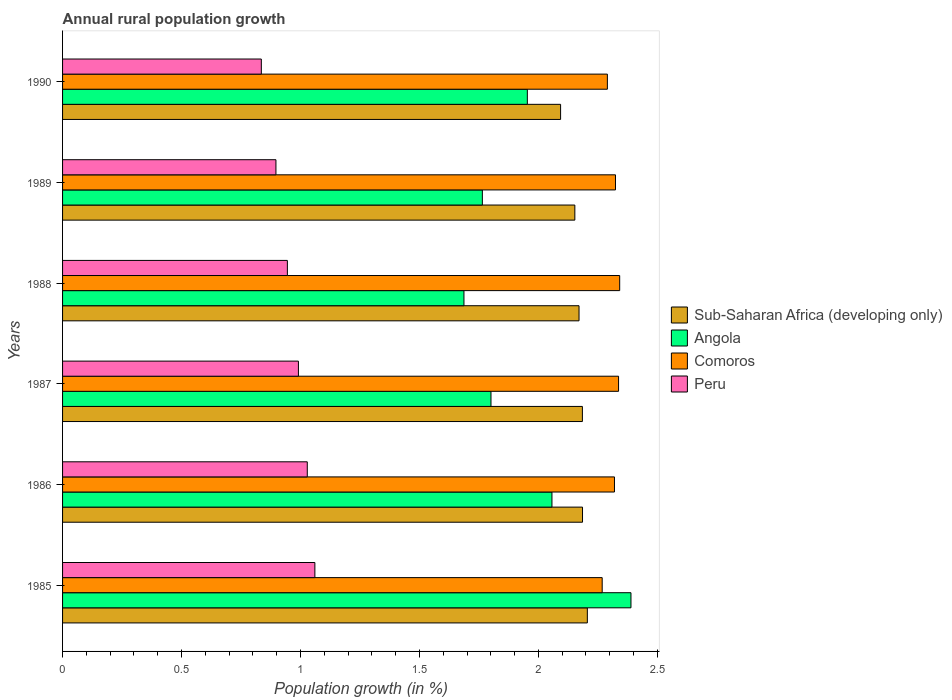How many different coloured bars are there?
Provide a short and direct response. 4. What is the percentage of rural population growth in Peru in 1989?
Provide a succinct answer. 0.9. Across all years, what is the maximum percentage of rural population growth in Peru?
Offer a very short reply. 1.06. Across all years, what is the minimum percentage of rural population growth in Peru?
Make the answer very short. 0.84. In which year was the percentage of rural population growth in Angola maximum?
Your response must be concise. 1985. What is the total percentage of rural population growth in Angola in the graph?
Give a very brief answer. 11.65. What is the difference between the percentage of rural population growth in Comoros in 1989 and that in 1990?
Offer a terse response. 0.03. What is the difference between the percentage of rural population growth in Sub-Saharan Africa (developing only) in 1987 and the percentage of rural population growth in Peru in 1989?
Offer a terse response. 1.29. What is the average percentage of rural population growth in Angola per year?
Your answer should be very brief. 1.94. In the year 1987, what is the difference between the percentage of rural population growth in Comoros and percentage of rural population growth in Peru?
Provide a succinct answer. 1.35. In how many years, is the percentage of rural population growth in Comoros greater than 0.30000000000000004 %?
Provide a succinct answer. 6. What is the ratio of the percentage of rural population growth in Sub-Saharan Africa (developing only) in 1985 to that in 1988?
Your response must be concise. 1.02. Is the percentage of rural population growth in Sub-Saharan Africa (developing only) in 1986 less than that in 1990?
Offer a terse response. No. What is the difference between the highest and the second highest percentage of rural population growth in Sub-Saharan Africa (developing only)?
Offer a terse response. 0.02. What is the difference between the highest and the lowest percentage of rural population growth in Peru?
Keep it short and to the point. 0.23. In how many years, is the percentage of rural population growth in Angola greater than the average percentage of rural population growth in Angola taken over all years?
Give a very brief answer. 3. Is it the case that in every year, the sum of the percentage of rural population growth in Sub-Saharan Africa (developing only) and percentage of rural population growth in Peru is greater than the sum of percentage of rural population growth in Angola and percentage of rural population growth in Comoros?
Keep it short and to the point. Yes. What does the 2nd bar from the top in 1987 represents?
Your response must be concise. Comoros. What does the 2nd bar from the bottom in 1990 represents?
Provide a succinct answer. Angola. How many years are there in the graph?
Ensure brevity in your answer.  6. Are the values on the major ticks of X-axis written in scientific E-notation?
Offer a very short reply. No. Does the graph contain any zero values?
Offer a terse response. No. Does the graph contain grids?
Give a very brief answer. No. Where does the legend appear in the graph?
Make the answer very short. Center right. What is the title of the graph?
Your answer should be compact. Annual rural population growth. What is the label or title of the X-axis?
Offer a very short reply. Population growth (in %). What is the Population growth (in %) in Sub-Saharan Africa (developing only) in 1985?
Your response must be concise. 2.21. What is the Population growth (in %) of Angola in 1985?
Offer a terse response. 2.39. What is the Population growth (in %) in Comoros in 1985?
Offer a terse response. 2.27. What is the Population growth (in %) of Peru in 1985?
Provide a short and direct response. 1.06. What is the Population growth (in %) of Sub-Saharan Africa (developing only) in 1986?
Provide a succinct answer. 2.19. What is the Population growth (in %) of Angola in 1986?
Provide a short and direct response. 2.06. What is the Population growth (in %) in Comoros in 1986?
Your response must be concise. 2.32. What is the Population growth (in %) in Peru in 1986?
Provide a succinct answer. 1.03. What is the Population growth (in %) of Sub-Saharan Africa (developing only) in 1987?
Keep it short and to the point. 2.18. What is the Population growth (in %) in Angola in 1987?
Provide a succinct answer. 1.8. What is the Population growth (in %) in Comoros in 1987?
Ensure brevity in your answer.  2.34. What is the Population growth (in %) in Peru in 1987?
Provide a short and direct response. 0.99. What is the Population growth (in %) in Sub-Saharan Africa (developing only) in 1988?
Make the answer very short. 2.17. What is the Population growth (in %) of Angola in 1988?
Provide a succinct answer. 1.69. What is the Population growth (in %) of Comoros in 1988?
Offer a terse response. 2.34. What is the Population growth (in %) in Peru in 1988?
Your answer should be very brief. 0.94. What is the Population growth (in %) of Sub-Saharan Africa (developing only) in 1989?
Your answer should be very brief. 2.15. What is the Population growth (in %) of Angola in 1989?
Ensure brevity in your answer.  1.76. What is the Population growth (in %) of Comoros in 1989?
Keep it short and to the point. 2.32. What is the Population growth (in %) in Peru in 1989?
Keep it short and to the point. 0.9. What is the Population growth (in %) of Sub-Saharan Africa (developing only) in 1990?
Ensure brevity in your answer.  2.09. What is the Population growth (in %) of Angola in 1990?
Keep it short and to the point. 1.95. What is the Population growth (in %) of Comoros in 1990?
Give a very brief answer. 2.29. What is the Population growth (in %) of Peru in 1990?
Offer a terse response. 0.84. Across all years, what is the maximum Population growth (in %) of Sub-Saharan Africa (developing only)?
Offer a very short reply. 2.21. Across all years, what is the maximum Population growth (in %) in Angola?
Your response must be concise. 2.39. Across all years, what is the maximum Population growth (in %) in Comoros?
Give a very brief answer. 2.34. Across all years, what is the maximum Population growth (in %) of Peru?
Offer a very short reply. 1.06. Across all years, what is the minimum Population growth (in %) in Sub-Saharan Africa (developing only)?
Give a very brief answer. 2.09. Across all years, what is the minimum Population growth (in %) of Angola?
Your answer should be very brief. 1.69. Across all years, what is the minimum Population growth (in %) of Comoros?
Offer a terse response. 2.27. Across all years, what is the minimum Population growth (in %) in Peru?
Make the answer very short. 0.84. What is the total Population growth (in %) in Sub-Saharan Africa (developing only) in the graph?
Provide a succinct answer. 12.99. What is the total Population growth (in %) in Angola in the graph?
Provide a succinct answer. 11.65. What is the total Population growth (in %) of Comoros in the graph?
Ensure brevity in your answer.  13.88. What is the total Population growth (in %) of Peru in the graph?
Offer a terse response. 5.76. What is the difference between the Population growth (in %) of Sub-Saharan Africa (developing only) in 1985 and that in 1986?
Keep it short and to the point. 0.02. What is the difference between the Population growth (in %) of Angola in 1985 and that in 1986?
Offer a very short reply. 0.33. What is the difference between the Population growth (in %) in Comoros in 1985 and that in 1986?
Keep it short and to the point. -0.05. What is the difference between the Population growth (in %) of Peru in 1985 and that in 1986?
Keep it short and to the point. 0.03. What is the difference between the Population growth (in %) of Sub-Saharan Africa (developing only) in 1985 and that in 1987?
Provide a succinct answer. 0.02. What is the difference between the Population growth (in %) of Angola in 1985 and that in 1987?
Offer a terse response. 0.59. What is the difference between the Population growth (in %) in Comoros in 1985 and that in 1987?
Make the answer very short. -0.07. What is the difference between the Population growth (in %) of Peru in 1985 and that in 1987?
Offer a very short reply. 0.07. What is the difference between the Population growth (in %) of Sub-Saharan Africa (developing only) in 1985 and that in 1988?
Your response must be concise. 0.03. What is the difference between the Population growth (in %) in Angola in 1985 and that in 1988?
Provide a short and direct response. 0.7. What is the difference between the Population growth (in %) of Comoros in 1985 and that in 1988?
Your answer should be very brief. -0.07. What is the difference between the Population growth (in %) of Peru in 1985 and that in 1988?
Provide a succinct answer. 0.12. What is the difference between the Population growth (in %) of Sub-Saharan Africa (developing only) in 1985 and that in 1989?
Offer a terse response. 0.05. What is the difference between the Population growth (in %) of Angola in 1985 and that in 1989?
Offer a very short reply. 0.62. What is the difference between the Population growth (in %) of Comoros in 1985 and that in 1989?
Ensure brevity in your answer.  -0.06. What is the difference between the Population growth (in %) in Peru in 1985 and that in 1989?
Offer a terse response. 0.16. What is the difference between the Population growth (in %) of Sub-Saharan Africa (developing only) in 1985 and that in 1990?
Your answer should be compact. 0.11. What is the difference between the Population growth (in %) in Angola in 1985 and that in 1990?
Your answer should be compact. 0.44. What is the difference between the Population growth (in %) in Comoros in 1985 and that in 1990?
Give a very brief answer. -0.02. What is the difference between the Population growth (in %) in Peru in 1985 and that in 1990?
Provide a succinct answer. 0.23. What is the difference between the Population growth (in %) in Angola in 1986 and that in 1987?
Keep it short and to the point. 0.26. What is the difference between the Population growth (in %) of Comoros in 1986 and that in 1987?
Provide a short and direct response. -0.02. What is the difference between the Population growth (in %) in Peru in 1986 and that in 1987?
Make the answer very short. 0.04. What is the difference between the Population growth (in %) in Sub-Saharan Africa (developing only) in 1986 and that in 1988?
Provide a short and direct response. 0.01. What is the difference between the Population growth (in %) in Angola in 1986 and that in 1988?
Offer a terse response. 0.37. What is the difference between the Population growth (in %) in Comoros in 1986 and that in 1988?
Your answer should be compact. -0.02. What is the difference between the Population growth (in %) of Peru in 1986 and that in 1988?
Your response must be concise. 0.08. What is the difference between the Population growth (in %) of Sub-Saharan Africa (developing only) in 1986 and that in 1989?
Ensure brevity in your answer.  0.03. What is the difference between the Population growth (in %) of Angola in 1986 and that in 1989?
Your response must be concise. 0.29. What is the difference between the Population growth (in %) of Comoros in 1986 and that in 1989?
Your answer should be compact. -0. What is the difference between the Population growth (in %) of Peru in 1986 and that in 1989?
Make the answer very short. 0.13. What is the difference between the Population growth (in %) of Sub-Saharan Africa (developing only) in 1986 and that in 1990?
Provide a succinct answer. 0.09. What is the difference between the Population growth (in %) of Angola in 1986 and that in 1990?
Give a very brief answer. 0.1. What is the difference between the Population growth (in %) in Comoros in 1986 and that in 1990?
Give a very brief answer. 0.03. What is the difference between the Population growth (in %) of Peru in 1986 and that in 1990?
Give a very brief answer. 0.19. What is the difference between the Population growth (in %) in Sub-Saharan Africa (developing only) in 1987 and that in 1988?
Offer a terse response. 0.01. What is the difference between the Population growth (in %) of Angola in 1987 and that in 1988?
Your response must be concise. 0.11. What is the difference between the Population growth (in %) in Comoros in 1987 and that in 1988?
Give a very brief answer. -0. What is the difference between the Population growth (in %) of Peru in 1987 and that in 1988?
Ensure brevity in your answer.  0.05. What is the difference between the Population growth (in %) in Sub-Saharan Africa (developing only) in 1987 and that in 1989?
Provide a succinct answer. 0.03. What is the difference between the Population growth (in %) of Angola in 1987 and that in 1989?
Give a very brief answer. 0.04. What is the difference between the Population growth (in %) in Comoros in 1987 and that in 1989?
Offer a terse response. 0.01. What is the difference between the Population growth (in %) in Peru in 1987 and that in 1989?
Keep it short and to the point. 0.09. What is the difference between the Population growth (in %) in Sub-Saharan Africa (developing only) in 1987 and that in 1990?
Provide a succinct answer. 0.09. What is the difference between the Population growth (in %) of Angola in 1987 and that in 1990?
Your answer should be very brief. -0.15. What is the difference between the Population growth (in %) in Comoros in 1987 and that in 1990?
Offer a very short reply. 0.05. What is the difference between the Population growth (in %) in Peru in 1987 and that in 1990?
Give a very brief answer. 0.16. What is the difference between the Population growth (in %) of Sub-Saharan Africa (developing only) in 1988 and that in 1989?
Your answer should be very brief. 0.02. What is the difference between the Population growth (in %) in Angola in 1988 and that in 1989?
Provide a succinct answer. -0.08. What is the difference between the Population growth (in %) in Comoros in 1988 and that in 1989?
Offer a very short reply. 0.02. What is the difference between the Population growth (in %) in Peru in 1988 and that in 1989?
Provide a succinct answer. 0.05. What is the difference between the Population growth (in %) of Sub-Saharan Africa (developing only) in 1988 and that in 1990?
Your answer should be compact. 0.08. What is the difference between the Population growth (in %) of Angola in 1988 and that in 1990?
Provide a short and direct response. -0.27. What is the difference between the Population growth (in %) of Comoros in 1988 and that in 1990?
Offer a very short reply. 0.05. What is the difference between the Population growth (in %) in Peru in 1988 and that in 1990?
Offer a terse response. 0.11. What is the difference between the Population growth (in %) in Sub-Saharan Africa (developing only) in 1989 and that in 1990?
Make the answer very short. 0.06. What is the difference between the Population growth (in %) in Angola in 1989 and that in 1990?
Your answer should be compact. -0.19. What is the difference between the Population growth (in %) of Comoros in 1989 and that in 1990?
Keep it short and to the point. 0.03. What is the difference between the Population growth (in %) of Peru in 1989 and that in 1990?
Your answer should be very brief. 0.06. What is the difference between the Population growth (in %) of Sub-Saharan Africa (developing only) in 1985 and the Population growth (in %) of Angola in 1986?
Your response must be concise. 0.15. What is the difference between the Population growth (in %) in Sub-Saharan Africa (developing only) in 1985 and the Population growth (in %) in Comoros in 1986?
Offer a terse response. -0.11. What is the difference between the Population growth (in %) of Sub-Saharan Africa (developing only) in 1985 and the Population growth (in %) of Peru in 1986?
Offer a terse response. 1.18. What is the difference between the Population growth (in %) of Angola in 1985 and the Population growth (in %) of Comoros in 1986?
Give a very brief answer. 0.07. What is the difference between the Population growth (in %) of Angola in 1985 and the Population growth (in %) of Peru in 1986?
Give a very brief answer. 1.36. What is the difference between the Population growth (in %) in Comoros in 1985 and the Population growth (in %) in Peru in 1986?
Ensure brevity in your answer.  1.24. What is the difference between the Population growth (in %) in Sub-Saharan Africa (developing only) in 1985 and the Population growth (in %) in Angola in 1987?
Your answer should be compact. 0.41. What is the difference between the Population growth (in %) in Sub-Saharan Africa (developing only) in 1985 and the Population growth (in %) in Comoros in 1987?
Provide a succinct answer. -0.13. What is the difference between the Population growth (in %) of Sub-Saharan Africa (developing only) in 1985 and the Population growth (in %) of Peru in 1987?
Give a very brief answer. 1.21. What is the difference between the Population growth (in %) in Angola in 1985 and the Population growth (in %) in Comoros in 1987?
Your answer should be compact. 0.05. What is the difference between the Population growth (in %) of Angola in 1985 and the Population growth (in %) of Peru in 1987?
Provide a succinct answer. 1.4. What is the difference between the Population growth (in %) of Comoros in 1985 and the Population growth (in %) of Peru in 1987?
Offer a very short reply. 1.28. What is the difference between the Population growth (in %) in Sub-Saharan Africa (developing only) in 1985 and the Population growth (in %) in Angola in 1988?
Give a very brief answer. 0.52. What is the difference between the Population growth (in %) of Sub-Saharan Africa (developing only) in 1985 and the Population growth (in %) of Comoros in 1988?
Offer a very short reply. -0.14. What is the difference between the Population growth (in %) of Sub-Saharan Africa (developing only) in 1985 and the Population growth (in %) of Peru in 1988?
Your response must be concise. 1.26. What is the difference between the Population growth (in %) of Angola in 1985 and the Population growth (in %) of Comoros in 1988?
Give a very brief answer. 0.05. What is the difference between the Population growth (in %) of Angola in 1985 and the Population growth (in %) of Peru in 1988?
Your answer should be compact. 1.44. What is the difference between the Population growth (in %) in Comoros in 1985 and the Population growth (in %) in Peru in 1988?
Offer a very short reply. 1.32. What is the difference between the Population growth (in %) in Sub-Saharan Africa (developing only) in 1985 and the Population growth (in %) in Angola in 1989?
Make the answer very short. 0.44. What is the difference between the Population growth (in %) in Sub-Saharan Africa (developing only) in 1985 and the Population growth (in %) in Comoros in 1989?
Keep it short and to the point. -0.12. What is the difference between the Population growth (in %) of Sub-Saharan Africa (developing only) in 1985 and the Population growth (in %) of Peru in 1989?
Keep it short and to the point. 1.31. What is the difference between the Population growth (in %) of Angola in 1985 and the Population growth (in %) of Comoros in 1989?
Offer a terse response. 0.07. What is the difference between the Population growth (in %) of Angola in 1985 and the Population growth (in %) of Peru in 1989?
Ensure brevity in your answer.  1.49. What is the difference between the Population growth (in %) in Comoros in 1985 and the Population growth (in %) in Peru in 1989?
Ensure brevity in your answer.  1.37. What is the difference between the Population growth (in %) in Sub-Saharan Africa (developing only) in 1985 and the Population growth (in %) in Angola in 1990?
Your answer should be very brief. 0.25. What is the difference between the Population growth (in %) of Sub-Saharan Africa (developing only) in 1985 and the Population growth (in %) of Comoros in 1990?
Your answer should be compact. -0.08. What is the difference between the Population growth (in %) in Sub-Saharan Africa (developing only) in 1985 and the Population growth (in %) in Peru in 1990?
Ensure brevity in your answer.  1.37. What is the difference between the Population growth (in %) of Angola in 1985 and the Population growth (in %) of Comoros in 1990?
Your response must be concise. 0.1. What is the difference between the Population growth (in %) of Angola in 1985 and the Population growth (in %) of Peru in 1990?
Offer a very short reply. 1.55. What is the difference between the Population growth (in %) of Comoros in 1985 and the Population growth (in %) of Peru in 1990?
Make the answer very short. 1.43. What is the difference between the Population growth (in %) of Sub-Saharan Africa (developing only) in 1986 and the Population growth (in %) of Angola in 1987?
Ensure brevity in your answer.  0.38. What is the difference between the Population growth (in %) of Sub-Saharan Africa (developing only) in 1986 and the Population growth (in %) of Comoros in 1987?
Keep it short and to the point. -0.15. What is the difference between the Population growth (in %) in Sub-Saharan Africa (developing only) in 1986 and the Population growth (in %) in Peru in 1987?
Offer a terse response. 1.19. What is the difference between the Population growth (in %) in Angola in 1986 and the Population growth (in %) in Comoros in 1987?
Your answer should be compact. -0.28. What is the difference between the Population growth (in %) of Angola in 1986 and the Population growth (in %) of Peru in 1987?
Ensure brevity in your answer.  1.07. What is the difference between the Population growth (in %) in Comoros in 1986 and the Population growth (in %) in Peru in 1987?
Offer a very short reply. 1.33. What is the difference between the Population growth (in %) of Sub-Saharan Africa (developing only) in 1986 and the Population growth (in %) of Angola in 1988?
Offer a terse response. 0.5. What is the difference between the Population growth (in %) of Sub-Saharan Africa (developing only) in 1986 and the Population growth (in %) of Comoros in 1988?
Keep it short and to the point. -0.16. What is the difference between the Population growth (in %) of Sub-Saharan Africa (developing only) in 1986 and the Population growth (in %) of Peru in 1988?
Provide a succinct answer. 1.24. What is the difference between the Population growth (in %) of Angola in 1986 and the Population growth (in %) of Comoros in 1988?
Offer a terse response. -0.28. What is the difference between the Population growth (in %) of Angola in 1986 and the Population growth (in %) of Peru in 1988?
Make the answer very short. 1.11. What is the difference between the Population growth (in %) in Comoros in 1986 and the Population growth (in %) in Peru in 1988?
Your answer should be very brief. 1.37. What is the difference between the Population growth (in %) of Sub-Saharan Africa (developing only) in 1986 and the Population growth (in %) of Angola in 1989?
Your response must be concise. 0.42. What is the difference between the Population growth (in %) in Sub-Saharan Africa (developing only) in 1986 and the Population growth (in %) in Comoros in 1989?
Make the answer very short. -0.14. What is the difference between the Population growth (in %) of Sub-Saharan Africa (developing only) in 1986 and the Population growth (in %) of Peru in 1989?
Make the answer very short. 1.29. What is the difference between the Population growth (in %) in Angola in 1986 and the Population growth (in %) in Comoros in 1989?
Your response must be concise. -0.27. What is the difference between the Population growth (in %) of Angola in 1986 and the Population growth (in %) of Peru in 1989?
Give a very brief answer. 1.16. What is the difference between the Population growth (in %) in Comoros in 1986 and the Population growth (in %) in Peru in 1989?
Provide a short and direct response. 1.42. What is the difference between the Population growth (in %) in Sub-Saharan Africa (developing only) in 1986 and the Population growth (in %) in Angola in 1990?
Give a very brief answer. 0.23. What is the difference between the Population growth (in %) in Sub-Saharan Africa (developing only) in 1986 and the Population growth (in %) in Comoros in 1990?
Your answer should be compact. -0.1. What is the difference between the Population growth (in %) in Sub-Saharan Africa (developing only) in 1986 and the Population growth (in %) in Peru in 1990?
Offer a terse response. 1.35. What is the difference between the Population growth (in %) of Angola in 1986 and the Population growth (in %) of Comoros in 1990?
Keep it short and to the point. -0.23. What is the difference between the Population growth (in %) of Angola in 1986 and the Population growth (in %) of Peru in 1990?
Provide a short and direct response. 1.22. What is the difference between the Population growth (in %) of Comoros in 1986 and the Population growth (in %) of Peru in 1990?
Your answer should be compact. 1.48. What is the difference between the Population growth (in %) of Sub-Saharan Africa (developing only) in 1987 and the Population growth (in %) of Angola in 1988?
Your answer should be very brief. 0.5. What is the difference between the Population growth (in %) of Sub-Saharan Africa (developing only) in 1987 and the Population growth (in %) of Comoros in 1988?
Make the answer very short. -0.16. What is the difference between the Population growth (in %) in Sub-Saharan Africa (developing only) in 1987 and the Population growth (in %) in Peru in 1988?
Provide a short and direct response. 1.24. What is the difference between the Population growth (in %) of Angola in 1987 and the Population growth (in %) of Comoros in 1988?
Offer a terse response. -0.54. What is the difference between the Population growth (in %) of Angola in 1987 and the Population growth (in %) of Peru in 1988?
Your answer should be very brief. 0.86. What is the difference between the Population growth (in %) in Comoros in 1987 and the Population growth (in %) in Peru in 1988?
Keep it short and to the point. 1.39. What is the difference between the Population growth (in %) in Sub-Saharan Africa (developing only) in 1987 and the Population growth (in %) in Angola in 1989?
Give a very brief answer. 0.42. What is the difference between the Population growth (in %) of Sub-Saharan Africa (developing only) in 1987 and the Population growth (in %) of Comoros in 1989?
Ensure brevity in your answer.  -0.14. What is the difference between the Population growth (in %) in Sub-Saharan Africa (developing only) in 1987 and the Population growth (in %) in Peru in 1989?
Keep it short and to the point. 1.29. What is the difference between the Population growth (in %) of Angola in 1987 and the Population growth (in %) of Comoros in 1989?
Provide a short and direct response. -0.52. What is the difference between the Population growth (in %) of Angola in 1987 and the Population growth (in %) of Peru in 1989?
Keep it short and to the point. 0.9. What is the difference between the Population growth (in %) in Comoros in 1987 and the Population growth (in %) in Peru in 1989?
Provide a short and direct response. 1.44. What is the difference between the Population growth (in %) in Sub-Saharan Africa (developing only) in 1987 and the Population growth (in %) in Angola in 1990?
Offer a terse response. 0.23. What is the difference between the Population growth (in %) of Sub-Saharan Africa (developing only) in 1987 and the Population growth (in %) of Comoros in 1990?
Offer a terse response. -0.1. What is the difference between the Population growth (in %) of Sub-Saharan Africa (developing only) in 1987 and the Population growth (in %) of Peru in 1990?
Your answer should be very brief. 1.35. What is the difference between the Population growth (in %) of Angola in 1987 and the Population growth (in %) of Comoros in 1990?
Keep it short and to the point. -0.49. What is the difference between the Population growth (in %) of Angola in 1987 and the Population growth (in %) of Peru in 1990?
Offer a terse response. 0.97. What is the difference between the Population growth (in %) in Comoros in 1987 and the Population growth (in %) in Peru in 1990?
Your answer should be very brief. 1.5. What is the difference between the Population growth (in %) in Sub-Saharan Africa (developing only) in 1988 and the Population growth (in %) in Angola in 1989?
Your response must be concise. 0.41. What is the difference between the Population growth (in %) of Sub-Saharan Africa (developing only) in 1988 and the Population growth (in %) of Comoros in 1989?
Provide a succinct answer. -0.15. What is the difference between the Population growth (in %) in Sub-Saharan Africa (developing only) in 1988 and the Population growth (in %) in Peru in 1989?
Ensure brevity in your answer.  1.27. What is the difference between the Population growth (in %) of Angola in 1988 and the Population growth (in %) of Comoros in 1989?
Offer a very short reply. -0.64. What is the difference between the Population growth (in %) in Angola in 1988 and the Population growth (in %) in Peru in 1989?
Provide a short and direct response. 0.79. What is the difference between the Population growth (in %) of Comoros in 1988 and the Population growth (in %) of Peru in 1989?
Keep it short and to the point. 1.44. What is the difference between the Population growth (in %) in Sub-Saharan Africa (developing only) in 1988 and the Population growth (in %) in Angola in 1990?
Keep it short and to the point. 0.22. What is the difference between the Population growth (in %) of Sub-Saharan Africa (developing only) in 1988 and the Population growth (in %) of Comoros in 1990?
Provide a short and direct response. -0.12. What is the difference between the Population growth (in %) of Sub-Saharan Africa (developing only) in 1988 and the Population growth (in %) of Peru in 1990?
Give a very brief answer. 1.34. What is the difference between the Population growth (in %) in Angola in 1988 and the Population growth (in %) in Comoros in 1990?
Ensure brevity in your answer.  -0.6. What is the difference between the Population growth (in %) of Angola in 1988 and the Population growth (in %) of Peru in 1990?
Offer a terse response. 0.85. What is the difference between the Population growth (in %) of Comoros in 1988 and the Population growth (in %) of Peru in 1990?
Your answer should be compact. 1.51. What is the difference between the Population growth (in %) in Sub-Saharan Africa (developing only) in 1989 and the Population growth (in %) in Angola in 1990?
Keep it short and to the point. 0.2. What is the difference between the Population growth (in %) in Sub-Saharan Africa (developing only) in 1989 and the Population growth (in %) in Comoros in 1990?
Give a very brief answer. -0.14. What is the difference between the Population growth (in %) in Sub-Saharan Africa (developing only) in 1989 and the Population growth (in %) in Peru in 1990?
Offer a terse response. 1.32. What is the difference between the Population growth (in %) in Angola in 1989 and the Population growth (in %) in Comoros in 1990?
Your response must be concise. -0.53. What is the difference between the Population growth (in %) in Angola in 1989 and the Population growth (in %) in Peru in 1990?
Your answer should be very brief. 0.93. What is the difference between the Population growth (in %) in Comoros in 1989 and the Population growth (in %) in Peru in 1990?
Make the answer very short. 1.49. What is the average Population growth (in %) of Sub-Saharan Africa (developing only) per year?
Your answer should be compact. 2.17. What is the average Population growth (in %) in Angola per year?
Make the answer very short. 1.94. What is the average Population growth (in %) of Comoros per year?
Offer a very short reply. 2.31. What is the average Population growth (in %) in Peru per year?
Your answer should be compact. 0.96. In the year 1985, what is the difference between the Population growth (in %) in Sub-Saharan Africa (developing only) and Population growth (in %) in Angola?
Your response must be concise. -0.18. In the year 1985, what is the difference between the Population growth (in %) in Sub-Saharan Africa (developing only) and Population growth (in %) in Comoros?
Give a very brief answer. -0.06. In the year 1985, what is the difference between the Population growth (in %) of Sub-Saharan Africa (developing only) and Population growth (in %) of Peru?
Offer a terse response. 1.15. In the year 1985, what is the difference between the Population growth (in %) in Angola and Population growth (in %) in Comoros?
Your response must be concise. 0.12. In the year 1985, what is the difference between the Population growth (in %) of Angola and Population growth (in %) of Peru?
Give a very brief answer. 1.33. In the year 1985, what is the difference between the Population growth (in %) of Comoros and Population growth (in %) of Peru?
Offer a terse response. 1.21. In the year 1986, what is the difference between the Population growth (in %) of Sub-Saharan Africa (developing only) and Population growth (in %) of Angola?
Keep it short and to the point. 0.13. In the year 1986, what is the difference between the Population growth (in %) in Sub-Saharan Africa (developing only) and Population growth (in %) in Comoros?
Your answer should be very brief. -0.13. In the year 1986, what is the difference between the Population growth (in %) of Sub-Saharan Africa (developing only) and Population growth (in %) of Peru?
Provide a short and direct response. 1.16. In the year 1986, what is the difference between the Population growth (in %) in Angola and Population growth (in %) in Comoros?
Provide a short and direct response. -0.26. In the year 1986, what is the difference between the Population growth (in %) of Angola and Population growth (in %) of Peru?
Offer a very short reply. 1.03. In the year 1986, what is the difference between the Population growth (in %) of Comoros and Population growth (in %) of Peru?
Your response must be concise. 1.29. In the year 1987, what is the difference between the Population growth (in %) of Sub-Saharan Africa (developing only) and Population growth (in %) of Angola?
Provide a short and direct response. 0.38. In the year 1987, what is the difference between the Population growth (in %) of Sub-Saharan Africa (developing only) and Population growth (in %) of Comoros?
Your answer should be very brief. -0.15. In the year 1987, what is the difference between the Population growth (in %) in Sub-Saharan Africa (developing only) and Population growth (in %) in Peru?
Provide a succinct answer. 1.19. In the year 1987, what is the difference between the Population growth (in %) of Angola and Population growth (in %) of Comoros?
Make the answer very short. -0.54. In the year 1987, what is the difference between the Population growth (in %) in Angola and Population growth (in %) in Peru?
Your answer should be very brief. 0.81. In the year 1987, what is the difference between the Population growth (in %) in Comoros and Population growth (in %) in Peru?
Give a very brief answer. 1.35. In the year 1988, what is the difference between the Population growth (in %) in Sub-Saharan Africa (developing only) and Population growth (in %) in Angola?
Provide a succinct answer. 0.48. In the year 1988, what is the difference between the Population growth (in %) in Sub-Saharan Africa (developing only) and Population growth (in %) in Comoros?
Your answer should be compact. -0.17. In the year 1988, what is the difference between the Population growth (in %) in Sub-Saharan Africa (developing only) and Population growth (in %) in Peru?
Give a very brief answer. 1.23. In the year 1988, what is the difference between the Population growth (in %) of Angola and Population growth (in %) of Comoros?
Your answer should be very brief. -0.65. In the year 1988, what is the difference between the Population growth (in %) of Angola and Population growth (in %) of Peru?
Your answer should be compact. 0.74. In the year 1988, what is the difference between the Population growth (in %) in Comoros and Population growth (in %) in Peru?
Offer a very short reply. 1.4. In the year 1989, what is the difference between the Population growth (in %) in Sub-Saharan Africa (developing only) and Population growth (in %) in Angola?
Offer a very short reply. 0.39. In the year 1989, what is the difference between the Population growth (in %) of Sub-Saharan Africa (developing only) and Population growth (in %) of Comoros?
Your response must be concise. -0.17. In the year 1989, what is the difference between the Population growth (in %) in Sub-Saharan Africa (developing only) and Population growth (in %) in Peru?
Provide a succinct answer. 1.26. In the year 1989, what is the difference between the Population growth (in %) of Angola and Population growth (in %) of Comoros?
Give a very brief answer. -0.56. In the year 1989, what is the difference between the Population growth (in %) of Angola and Population growth (in %) of Peru?
Your response must be concise. 0.87. In the year 1989, what is the difference between the Population growth (in %) in Comoros and Population growth (in %) in Peru?
Ensure brevity in your answer.  1.43. In the year 1990, what is the difference between the Population growth (in %) of Sub-Saharan Africa (developing only) and Population growth (in %) of Angola?
Your answer should be very brief. 0.14. In the year 1990, what is the difference between the Population growth (in %) in Sub-Saharan Africa (developing only) and Population growth (in %) in Comoros?
Make the answer very short. -0.2. In the year 1990, what is the difference between the Population growth (in %) in Sub-Saharan Africa (developing only) and Population growth (in %) in Peru?
Give a very brief answer. 1.26. In the year 1990, what is the difference between the Population growth (in %) of Angola and Population growth (in %) of Comoros?
Provide a succinct answer. -0.34. In the year 1990, what is the difference between the Population growth (in %) in Angola and Population growth (in %) in Peru?
Give a very brief answer. 1.12. In the year 1990, what is the difference between the Population growth (in %) in Comoros and Population growth (in %) in Peru?
Keep it short and to the point. 1.45. What is the ratio of the Population growth (in %) of Sub-Saharan Africa (developing only) in 1985 to that in 1986?
Your answer should be compact. 1.01. What is the ratio of the Population growth (in %) of Angola in 1985 to that in 1986?
Offer a terse response. 1.16. What is the ratio of the Population growth (in %) of Comoros in 1985 to that in 1986?
Give a very brief answer. 0.98. What is the ratio of the Population growth (in %) of Peru in 1985 to that in 1986?
Your response must be concise. 1.03. What is the ratio of the Population growth (in %) in Sub-Saharan Africa (developing only) in 1985 to that in 1987?
Provide a short and direct response. 1.01. What is the ratio of the Population growth (in %) of Angola in 1985 to that in 1987?
Provide a succinct answer. 1.33. What is the ratio of the Population growth (in %) in Comoros in 1985 to that in 1987?
Your response must be concise. 0.97. What is the ratio of the Population growth (in %) of Peru in 1985 to that in 1987?
Provide a short and direct response. 1.07. What is the ratio of the Population growth (in %) in Sub-Saharan Africa (developing only) in 1985 to that in 1988?
Ensure brevity in your answer.  1.02. What is the ratio of the Population growth (in %) of Angola in 1985 to that in 1988?
Keep it short and to the point. 1.42. What is the ratio of the Population growth (in %) of Comoros in 1985 to that in 1988?
Make the answer very short. 0.97. What is the ratio of the Population growth (in %) of Peru in 1985 to that in 1988?
Your answer should be very brief. 1.12. What is the ratio of the Population growth (in %) in Sub-Saharan Africa (developing only) in 1985 to that in 1989?
Ensure brevity in your answer.  1.02. What is the ratio of the Population growth (in %) of Angola in 1985 to that in 1989?
Provide a short and direct response. 1.35. What is the ratio of the Population growth (in %) in Comoros in 1985 to that in 1989?
Make the answer very short. 0.98. What is the ratio of the Population growth (in %) of Peru in 1985 to that in 1989?
Offer a terse response. 1.18. What is the ratio of the Population growth (in %) in Sub-Saharan Africa (developing only) in 1985 to that in 1990?
Provide a short and direct response. 1.05. What is the ratio of the Population growth (in %) in Angola in 1985 to that in 1990?
Provide a short and direct response. 1.22. What is the ratio of the Population growth (in %) of Comoros in 1985 to that in 1990?
Your answer should be compact. 0.99. What is the ratio of the Population growth (in %) of Peru in 1985 to that in 1990?
Your response must be concise. 1.27. What is the ratio of the Population growth (in %) of Sub-Saharan Africa (developing only) in 1986 to that in 1987?
Provide a succinct answer. 1. What is the ratio of the Population growth (in %) of Angola in 1986 to that in 1987?
Provide a short and direct response. 1.14. What is the ratio of the Population growth (in %) of Comoros in 1986 to that in 1987?
Make the answer very short. 0.99. What is the ratio of the Population growth (in %) in Peru in 1986 to that in 1987?
Your response must be concise. 1.04. What is the ratio of the Population growth (in %) of Sub-Saharan Africa (developing only) in 1986 to that in 1988?
Ensure brevity in your answer.  1.01. What is the ratio of the Population growth (in %) in Angola in 1986 to that in 1988?
Ensure brevity in your answer.  1.22. What is the ratio of the Population growth (in %) of Comoros in 1986 to that in 1988?
Provide a succinct answer. 0.99. What is the ratio of the Population growth (in %) in Peru in 1986 to that in 1988?
Your answer should be compact. 1.09. What is the ratio of the Population growth (in %) of Sub-Saharan Africa (developing only) in 1986 to that in 1989?
Your answer should be very brief. 1.01. What is the ratio of the Population growth (in %) in Angola in 1986 to that in 1989?
Offer a very short reply. 1.17. What is the ratio of the Population growth (in %) of Peru in 1986 to that in 1989?
Offer a terse response. 1.15. What is the ratio of the Population growth (in %) of Sub-Saharan Africa (developing only) in 1986 to that in 1990?
Your answer should be compact. 1.04. What is the ratio of the Population growth (in %) in Angola in 1986 to that in 1990?
Offer a very short reply. 1.05. What is the ratio of the Population growth (in %) in Peru in 1986 to that in 1990?
Ensure brevity in your answer.  1.23. What is the ratio of the Population growth (in %) in Sub-Saharan Africa (developing only) in 1987 to that in 1988?
Provide a short and direct response. 1.01. What is the ratio of the Population growth (in %) of Angola in 1987 to that in 1988?
Offer a terse response. 1.07. What is the ratio of the Population growth (in %) of Comoros in 1987 to that in 1988?
Give a very brief answer. 1. What is the ratio of the Population growth (in %) of Peru in 1987 to that in 1988?
Keep it short and to the point. 1.05. What is the ratio of the Population growth (in %) in Sub-Saharan Africa (developing only) in 1987 to that in 1989?
Your response must be concise. 1.01. What is the ratio of the Population growth (in %) of Angola in 1987 to that in 1989?
Make the answer very short. 1.02. What is the ratio of the Population growth (in %) in Comoros in 1987 to that in 1989?
Your answer should be compact. 1.01. What is the ratio of the Population growth (in %) of Peru in 1987 to that in 1989?
Your answer should be very brief. 1.11. What is the ratio of the Population growth (in %) of Sub-Saharan Africa (developing only) in 1987 to that in 1990?
Your answer should be very brief. 1.04. What is the ratio of the Population growth (in %) in Angola in 1987 to that in 1990?
Give a very brief answer. 0.92. What is the ratio of the Population growth (in %) in Comoros in 1987 to that in 1990?
Provide a short and direct response. 1.02. What is the ratio of the Population growth (in %) in Peru in 1987 to that in 1990?
Your answer should be compact. 1.19. What is the ratio of the Population growth (in %) in Sub-Saharan Africa (developing only) in 1988 to that in 1989?
Provide a short and direct response. 1.01. What is the ratio of the Population growth (in %) of Angola in 1988 to that in 1989?
Ensure brevity in your answer.  0.96. What is the ratio of the Population growth (in %) in Comoros in 1988 to that in 1989?
Ensure brevity in your answer.  1.01. What is the ratio of the Population growth (in %) in Peru in 1988 to that in 1989?
Your response must be concise. 1.05. What is the ratio of the Population growth (in %) of Angola in 1988 to that in 1990?
Offer a terse response. 0.86. What is the ratio of the Population growth (in %) of Comoros in 1988 to that in 1990?
Your answer should be compact. 1.02. What is the ratio of the Population growth (in %) of Peru in 1988 to that in 1990?
Your answer should be compact. 1.13. What is the ratio of the Population growth (in %) in Sub-Saharan Africa (developing only) in 1989 to that in 1990?
Your response must be concise. 1.03. What is the ratio of the Population growth (in %) in Angola in 1989 to that in 1990?
Make the answer very short. 0.9. What is the ratio of the Population growth (in %) of Comoros in 1989 to that in 1990?
Ensure brevity in your answer.  1.01. What is the ratio of the Population growth (in %) of Peru in 1989 to that in 1990?
Provide a succinct answer. 1.07. What is the difference between the highest and the second highest Population growth (in %) in Sub-Saharan Africa (developing only)?
Provide a short and direct response. 0.02. What is the difference between the highest and the second highest Population growth (in %) of Angola?
Ensure brevity in your answer.  0.33. What is the difference between the highest and the second highest Population growth (in %) of Comoros?
Offer a very short reply. 0. What is the difference between the highest and the second highest Population growth (in %) of Peru?
Your response must be concise. 0.03. What is the difference between the highest and the lowest Population growth (in %) of Sub-Saharan Africa (developing only)?
Give a very brief answer. 0.11. What is the difference between the highest and the lowest Population growth (in %) in Angola?
Keep it short and to the point. 0.7. What is the difference between the highest and the lowest Population growth (in %) of Comoros?
Your response must be concise. 0.07. What is the difference between the highest and the lowest Population growth (in %) in Peru?
Ensure brevity in your answer.  0.23. 